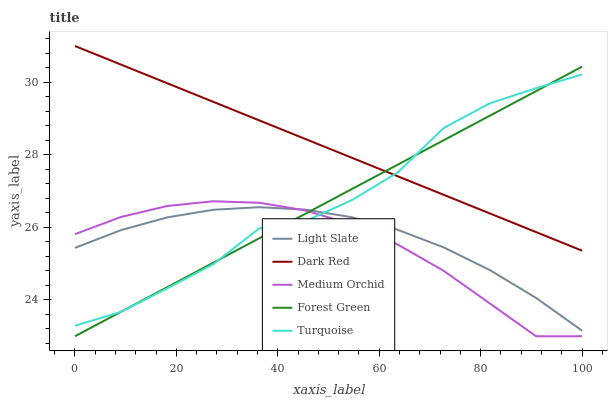Does Medium Orchid have the minimum area under the curve?
Answer yes or no. Yes. Does Dark Red have the maximum area under the curve?
Answer yes or no. Yes. Does Forest Green have the minimum area under the curve?
Answer yes or no. No. Does Forest Green have the maximum area under the curve?
Answer yes or no. No. Is Forest Green the smoothest?
Answer yes or no. Yes. Is Turquoise the roughest?
Answer yes or no. Yes. Is Dark Red the smoothest?
Answer yes or no. No. Is Dark Red the roughest?
Answer yes or no. No. Does Dark Red have the lowest value?
Answer yes or no. No. Does Dark Red have the highest value?
Answer yes or no. Yes. Does Forest Green have the highest value?
Answer yes or no. No. Is Medium Orchid less than Dark Red?
Answer yes or no. Yes. Is Dark Red greater than Light Slate?
Answer yes or no. Yes. Does Light Slate intersect Medium Orchid?
Answer yes or no. Yes. Is Light Slate less than Medium Orchid?
Answer yes or no. No. Is Light Slate greater than Medium Orchid?
Answer yes or no. No. Does Medium Orchid intersect Dark Red?
Answer yes or no. No. 